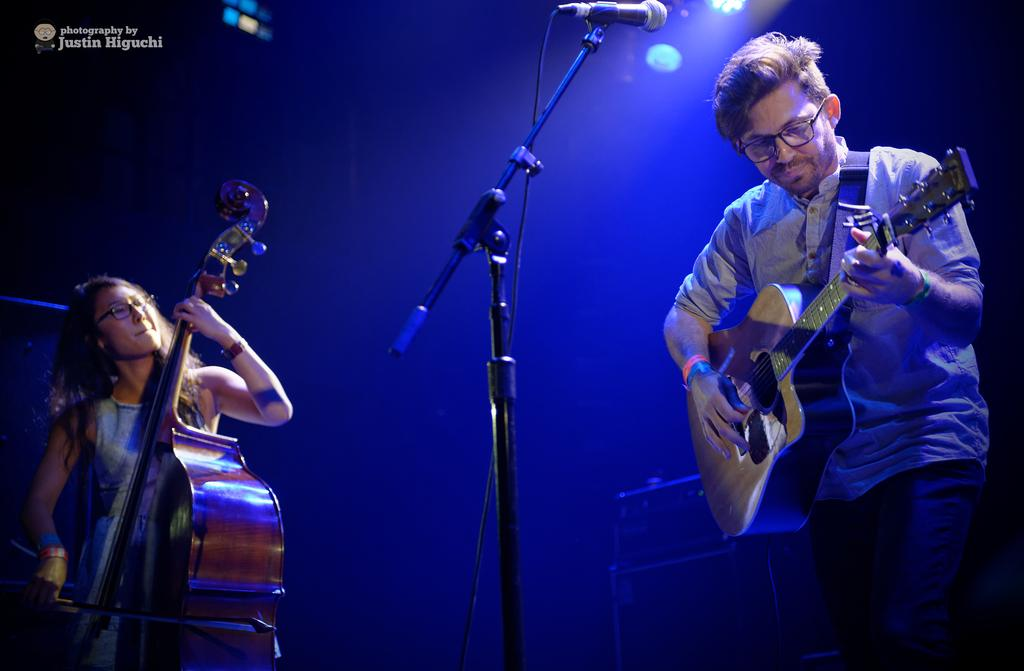How many people are in the image? There are two people in the image, a man and a woman. What are the man and the woman doing in the image? Both the man and the woman are holding musical instruments. Can you describe the man's position in the image? The man is in front of a microphone (mic). What type of hole can be seen in the image? There is no hole present in the image. What kind of test is being conducted in the image? There is no test being conducted in the image. 